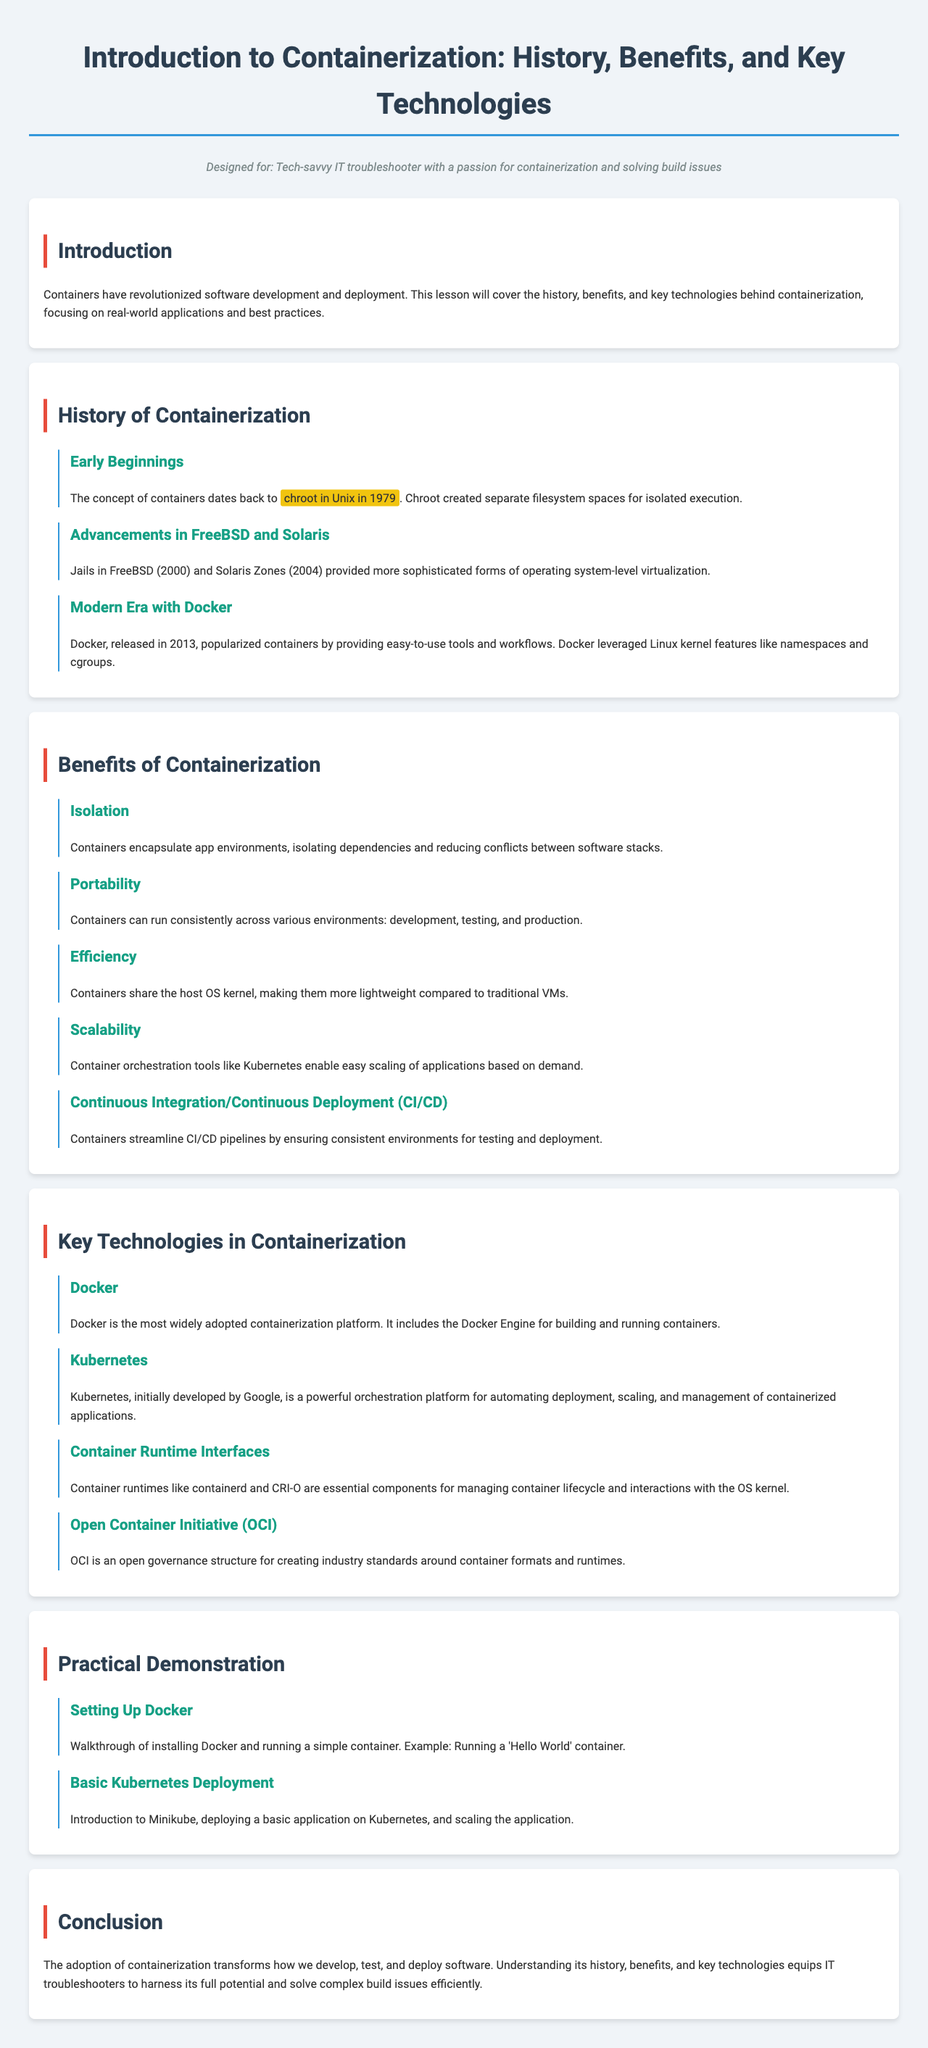What year did chroot in Unix originate? The document states that the concept of containers dates back to chroot in Unix in 1979.
Answer: 1979 What is the key technology released in 2013 that popularized containers? The document mentions that Docker, released in 2013, popularized containers.
Answer: Docker Which container orchestration tool is mentioned in relation to scalability? The document highlights Kubernetes as a container orchestration tool enabling easy scaling of applications.
Answer: Kubernetes What is one key feature of Docker? According to the document, Docker includes the Docker Engine for building and running containers.
Answer: Docker Engine What does OCI stand for? The document defines OCI as the Open Container Initiative.
Answer: Open Container Initiative How many benefits of containerization are listed in the document? The document lists five benefits of containerization, indicating the efficient nature of the information provided.
Answer: Five What practical demonstration is featured related to Kubernetes? The document includes an introduction to Minikube in the practical demonstration section.
Answer: Minikube What significance does containerization have for IT troubleshooters? The document concludes that understanding containerization helps troubleshooters solve complex build issues efficiently.
Answer: Solve complex build issues efficiently What type of virtualization did Solaris Zones provide? The document states that Solaris Zones provided more sophisticated forms of operating system-level virtualization.
Answer: Operating system-level virtualization 